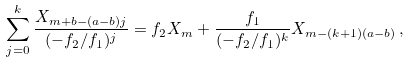<formula> <loc_0><loc_0><loc_500><loc_500>\sum _ { j = 0 } ^ { k } { \frac { { X _ { m + b - ( a - b ) j } } } { ( - f _ { 2 } / f _ { 1 } ) ^ { j } } } = f _ { 2 } X _ { m } + \frac { f _ { 1 } } { ( - f _ { 2 } / f _ { 1 } ) ^ { k } } X _ { m - ( k + 1 ) ( a - b ) } \, ,</formula> 